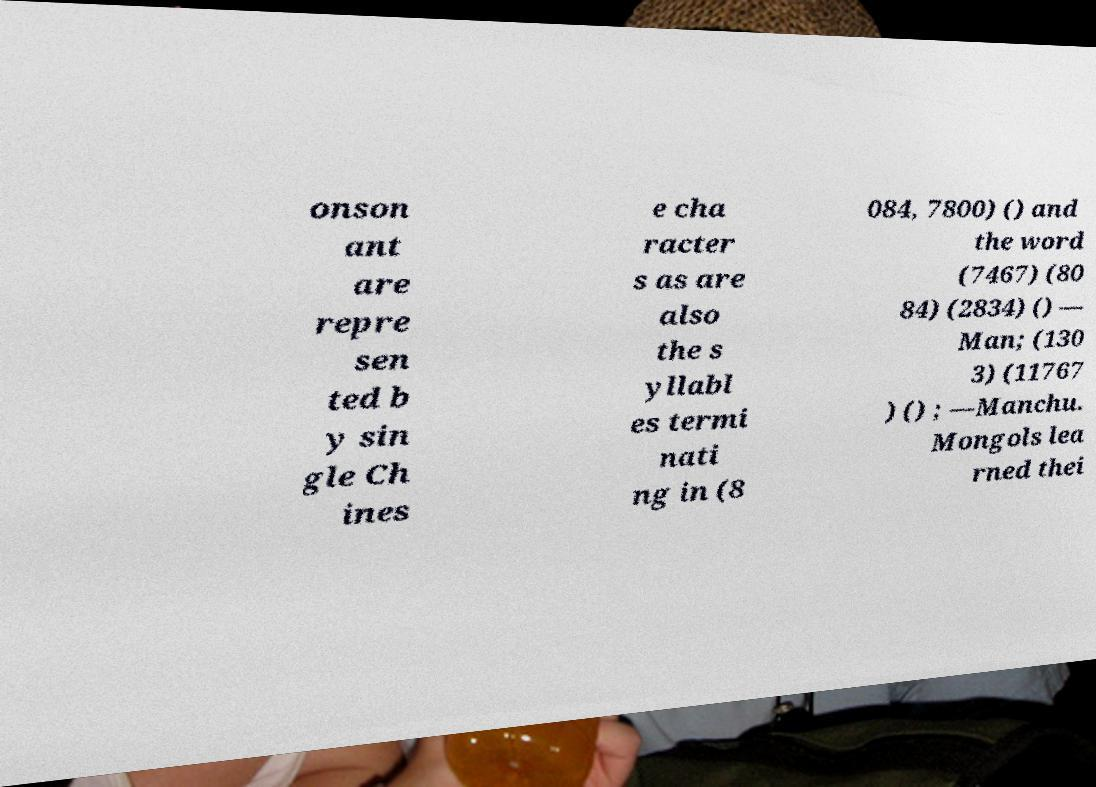Could you extract and type out the text from this image? onson ant are repre sen ted b y sin gle Ch ines e cha racter s as are also the s yllabl es termi nati ng in (8 084, 7800) () and the word (7467) (80 84) (2834) () — Man; (130 3) (11767 ) () ; —Manchu. Mongols lea rned thei 